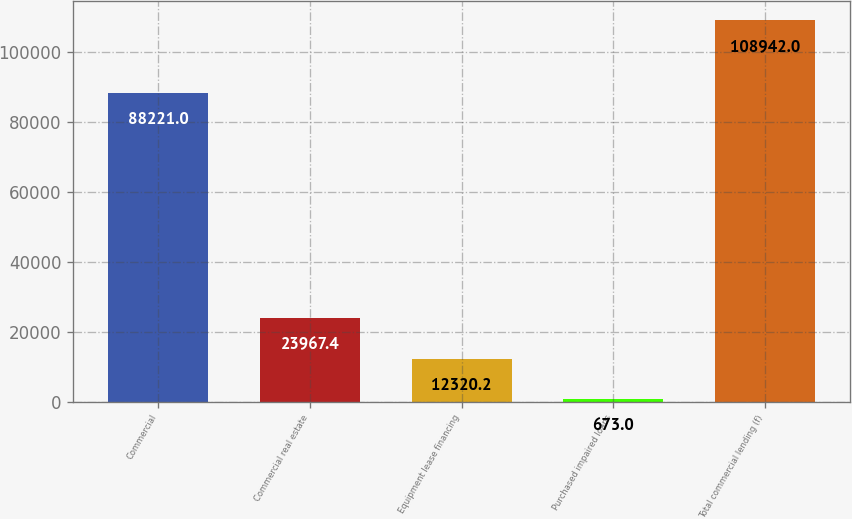Convert chart. <chart><loc_0><loc_0><loc_500><loc_500><bar_chart><fcel>Commercial<fcel>Commercial real estate<fcel>Equipment lease financing<fcel>Purchased impaired loans<fcel>Total commercial lending (f)<nl><fcel>88221<fcel>23967.4<fcel>12320.2<fcel>673<fcel>108942<nl></chart> 